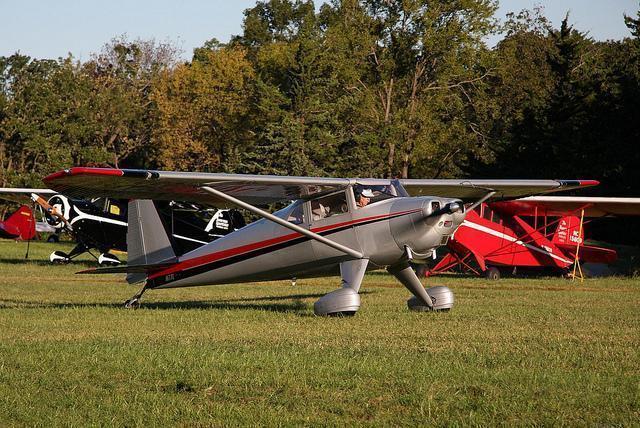What powers this plane?
Choose the right answer and clarify with the format: 'Answer: answer
Rationale: rationale.'
Options: Coal, kerosene, gasoline, electricity. Answer: gasoline.
Rationale: The plane sitting on the gas is powered by gasoline when running. 